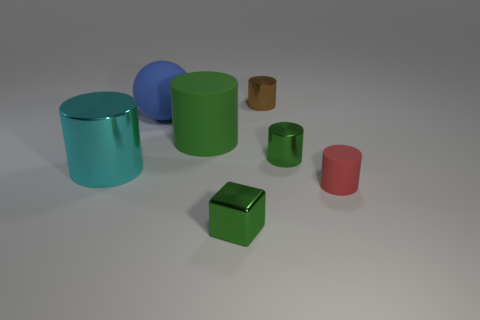Add 1 green rubber cylinders. How many objects exist? 8 Subtract all cyan cylinders. How many cylinders are left? 4 Subtract all small red matte cylinders. How many cylinders are left? 4 Subtract 2 cylinders. How many cylinders are left? 3 Add 2 small red matte things. How many small red matte things are left? 3 Add 5 large shiny spheres. How many large shiny spheres exist? 5 Subtract 0 gray cylinders. How many objects are left? 7 Subtract all blocks. How many objects are left? 6 Subtract all purple blocks. Subtract all yellow cylinders. How many blocks are left? 1 Subtract all green cylinders. How many cyan cubes are left? 0 